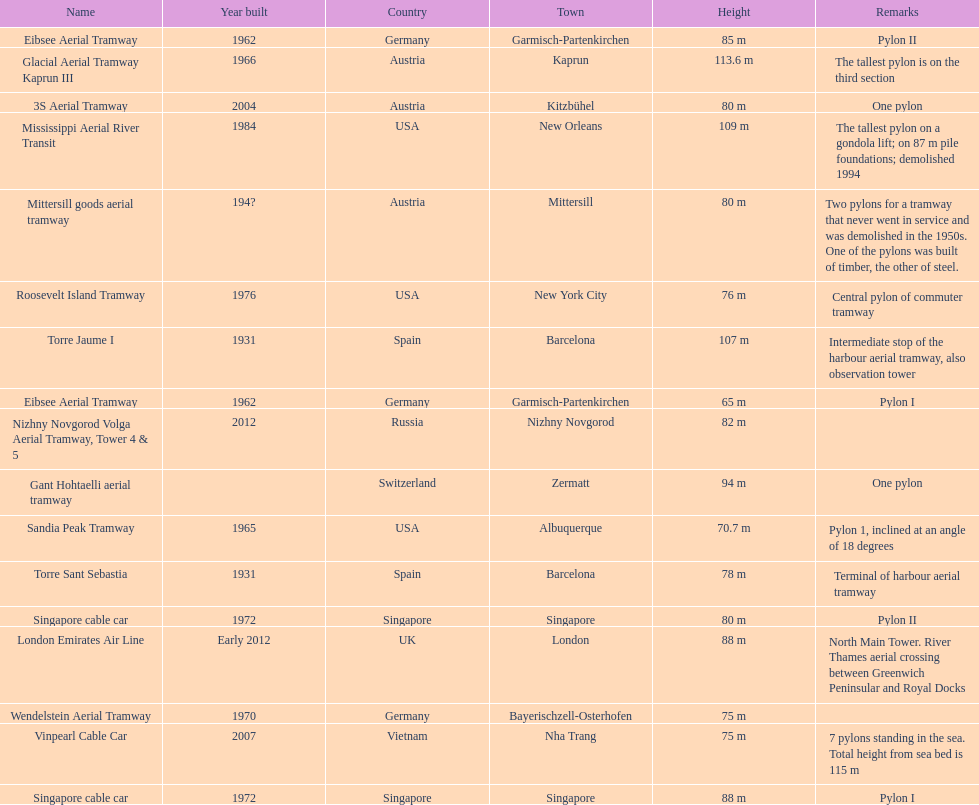Parse the full table. {'header': ['Name', 'Year built', 'Country', 'Town', 'Height', 'Remarks'], 'rows': [['Eibsee Aerial Tramway', '1962', 'Germany', 'Garmisch-Partenkirchen', '85 m', 'Pylon II'], ['Glacial Aerial Tramway Kaprun III', '1966', 'Austria', 'Kaprun', '113.6 m', 'The tallest pylon is on the third section'], ['3S Aerial Tramway', '2004', 'Austria', 'Kitzbühel', '80 m', 'One pylon'], ['Mississippi Aerial River Transit', '1984', 'USA', 'New Orleans', '109 m', 'The tallest pylon on a gondola lift; on 87 m pile foundations; demolished 1994'], ['Mittersill goods aerial tramway', '194?', 'Austria', 'Mittersill', '80 m', 'Two pylons for a tramway that never went in service and was demolished in the 1950s. One of the pylons was built of timber, the other of steel.'], ['Roosevelt Island Tramway', '1976', 'USA', 'New York City', '76 m', 'Central pylon of commuter tramway'], ['Torre Jaume I', '1931', 'Spain', 'Barcelona', '107 m', 'Intermediate stop of the harbour aerial tramway, also observation tower'], ['Eibsee Aerial Tramway', '1962', 'Germany', 'Garmisch-Partenkirchen', '65 m', 'Pylon I'], ['Nizhny Novgorod Volga Aerial Tramway, Tower 4 & 5', '2012', 'Russia', 'Nizhny Novgorod', '82 m', ''], ['Gant Hohtaelli aerial tramway', '', 'Switzerland', 'Zermatt', '94 m', 'One pylon'], ['Sandia Peak Tramway', '1965', 'USA', 'Albuquerque', '70.7 m', 'Pylon 1, inclined at an angle of 18 degrees'], ['Torre Sant Sebastia', '1931', 'Spain', 'Barcelona', '78 m', 'Terminal of harbour aerial tramway'], ['Singapore cable car', '1972', 'Singapore', 'Singapore', '80 m', 'Pylon II'], ['London Emirates Air Line', 'Early 2012', 'UK', 'London', '88 m', 'North Main Tower. River Thames aerial crossing between Greenwich Peninsular and Royal Docks'], ['Wendelstein Aerial Tramway', '1970', 'Germany', 'Bayerischzell-Osterhofen', '75 m', ''], ['Vinpearl Cable Car', '2007', 'Vietnam', 'Nha Trang', '75 m', '7 pylons standing in the sea. Total height from sea bed is 115 m'], ['Singapore cable car', '1972', 'Singapore', 'Singapore', '88 m', 'Pylon I']]} What is the pylon with the least height listed here? Eibsee Aerial Tramway. 